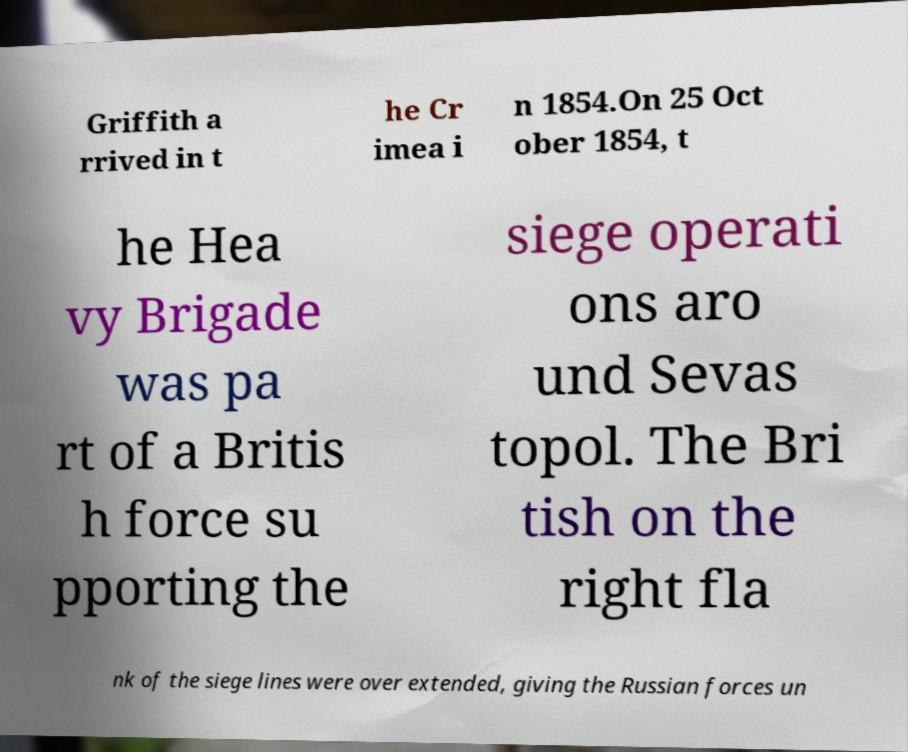What messages or text are displayed in this image? I need them in a readable, typed format. Griffith a rrived in t he Cr imea i n 1854.On 25 Oct ober 1854, t he Hea vy Brigade was pa rt of a Britis h force su pporting the siege operati ons aro und Sevas topol. The Bri tish on the right fla nk of the siege lines were over extended, giving the Russian forces un 